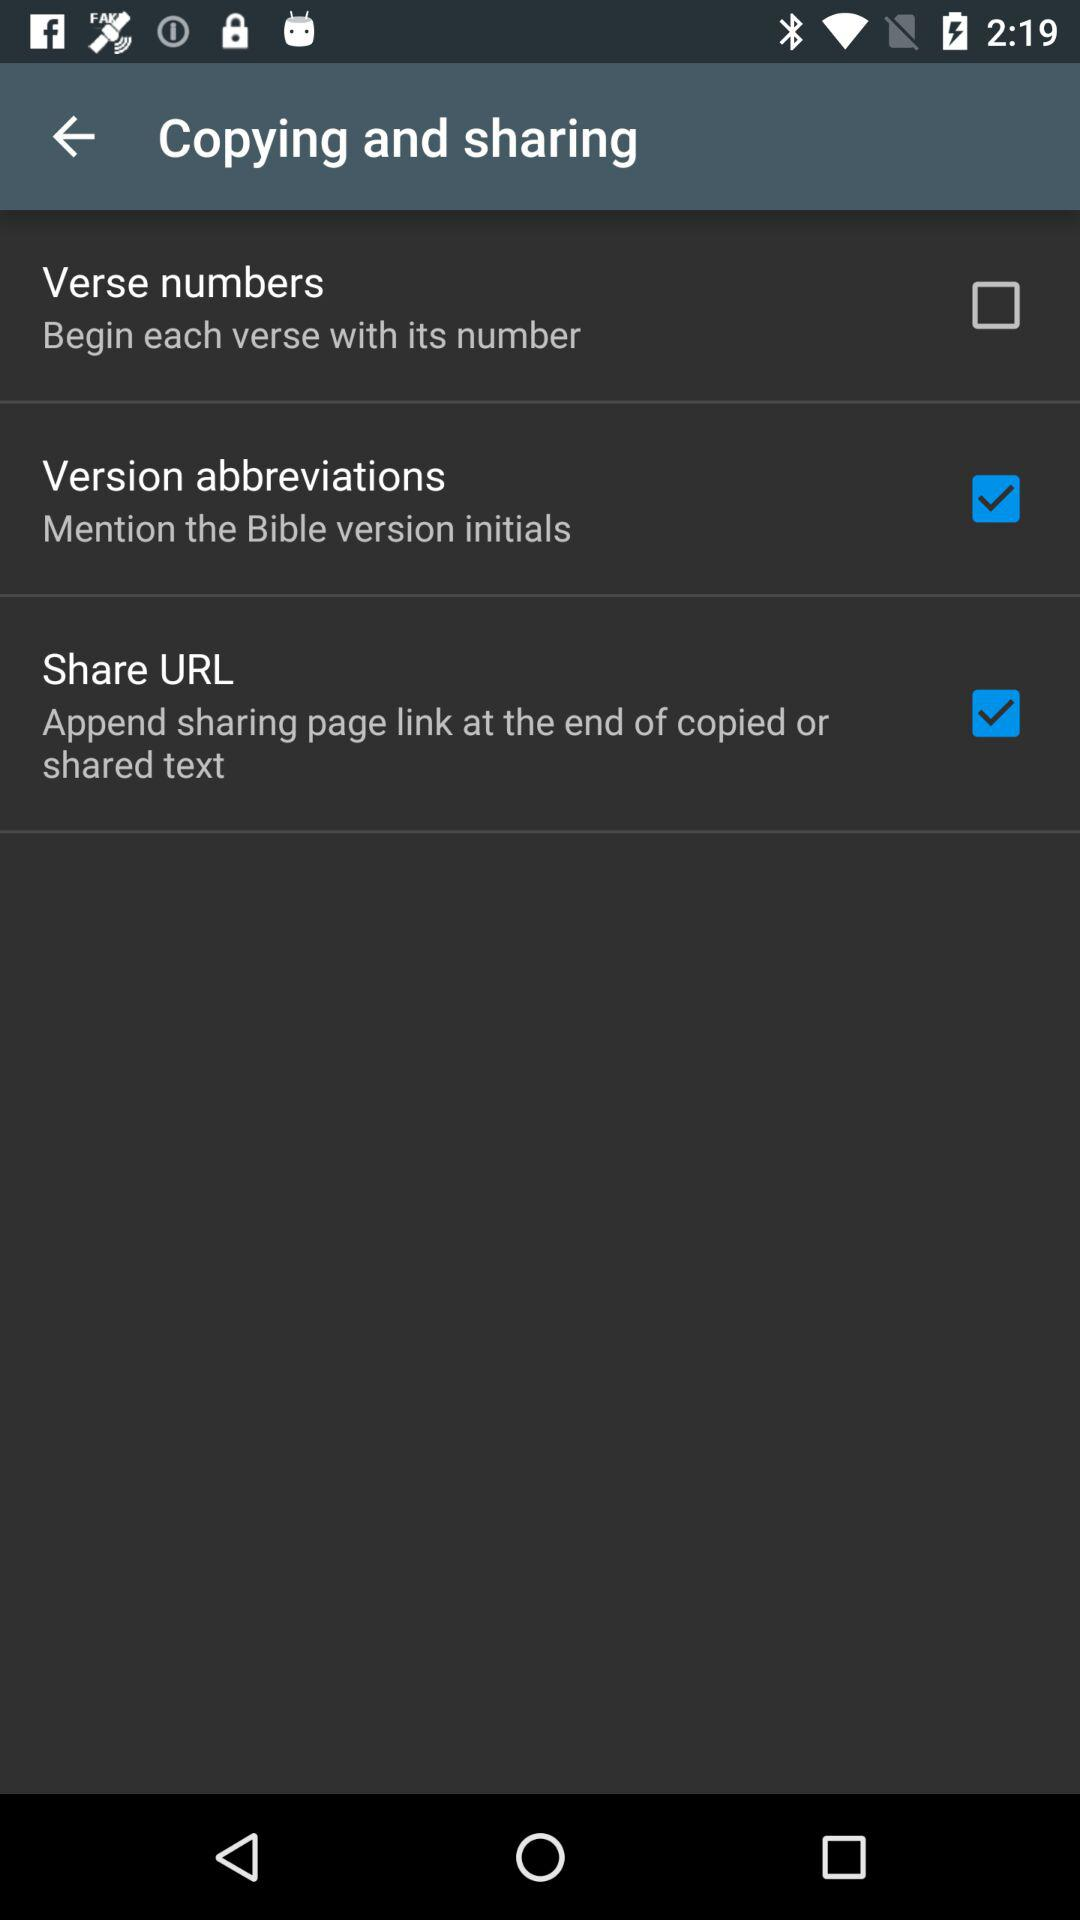What's the status of "Share URL"? The status of "Share URL" is "on". 